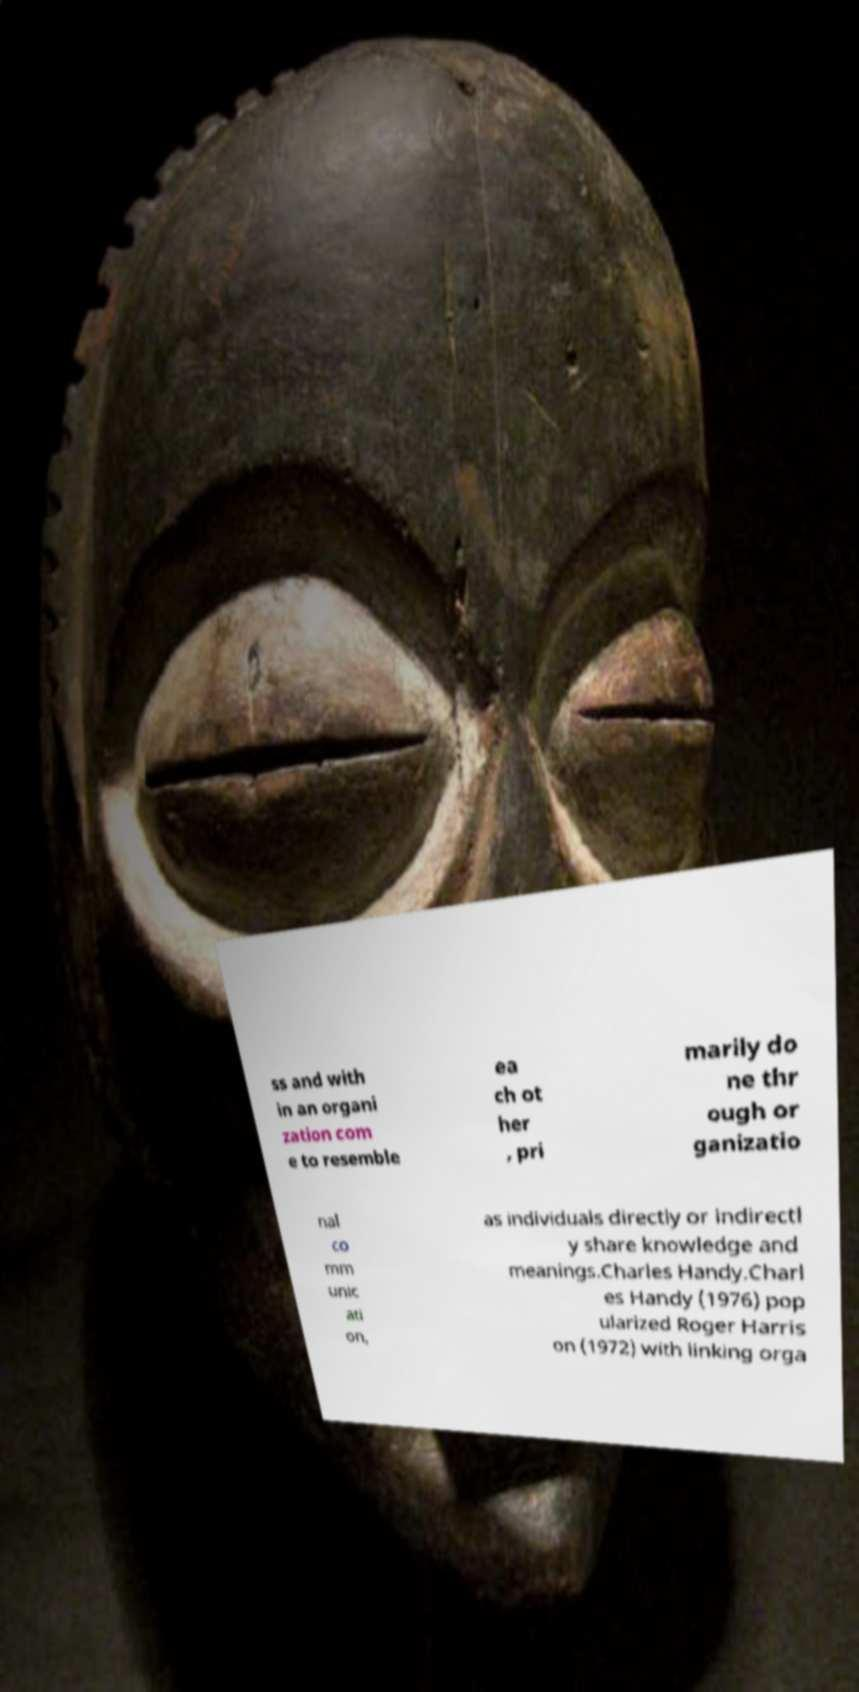Please read and relay the text visible in this image. What does it say? ss and with in an organi zation com e to resemble ea ch ot her , pri marily do ne thr ough or ganizatio nal co mm unic ati on, as individuals directly or indirectl y share knowledge and meanings.Charles Handy.Charl es Handy (1976) pop ularized Roger Harris on (1972) with linking orga 